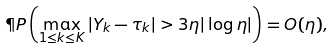<formula> <loc_0><loc_0><loc_500><loc_500>\P P \left ( \max _ { 1 \leq k \leq K } | Y _ { k } - \tau _ { k } | > 3 \eta | \log \eta | \right ) = O ( \eta ) ,</formula> 